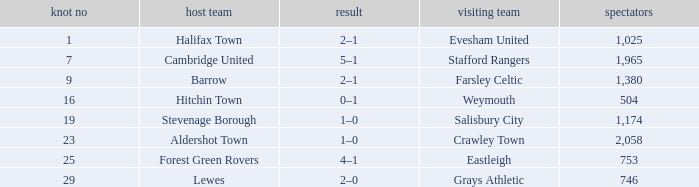How many attended tie number 19? 1174.0. 